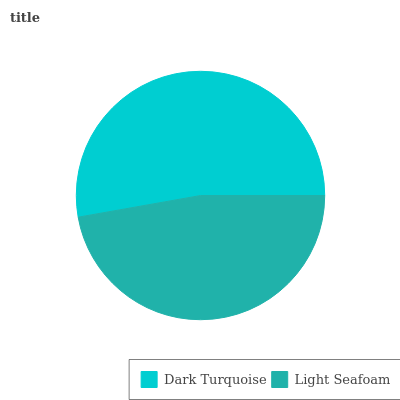Is Light Seafoam the minimum?
Answer yes or no. Yes. Is Dark Turquoise the maximum?
Answer yes or no. Yes. Is Light Seafoam the maximum?
Answer yes or no. No. Is Dark Turquoise greater than Light Seafoam?
Answer yes or no. Yes. Is Light Seafoam less than Dark Turquoise?
Answer yes or no. Yes. Is Light Seafoam greater than Dark Turquoise?
Answer yes or no. No. Is Dark Turquoise less than Light Seafoam?
Answer yes or no. No. Is Dark Turquoise the high median?
Answer yes or no. Yes. Is Light Seafoam the low median?
Answer yes or no. Yes. Is Light Seafoam the high median?
Answer yes or no. No. Is Dark Turquoise the low median?
Answer yes or no. No. 